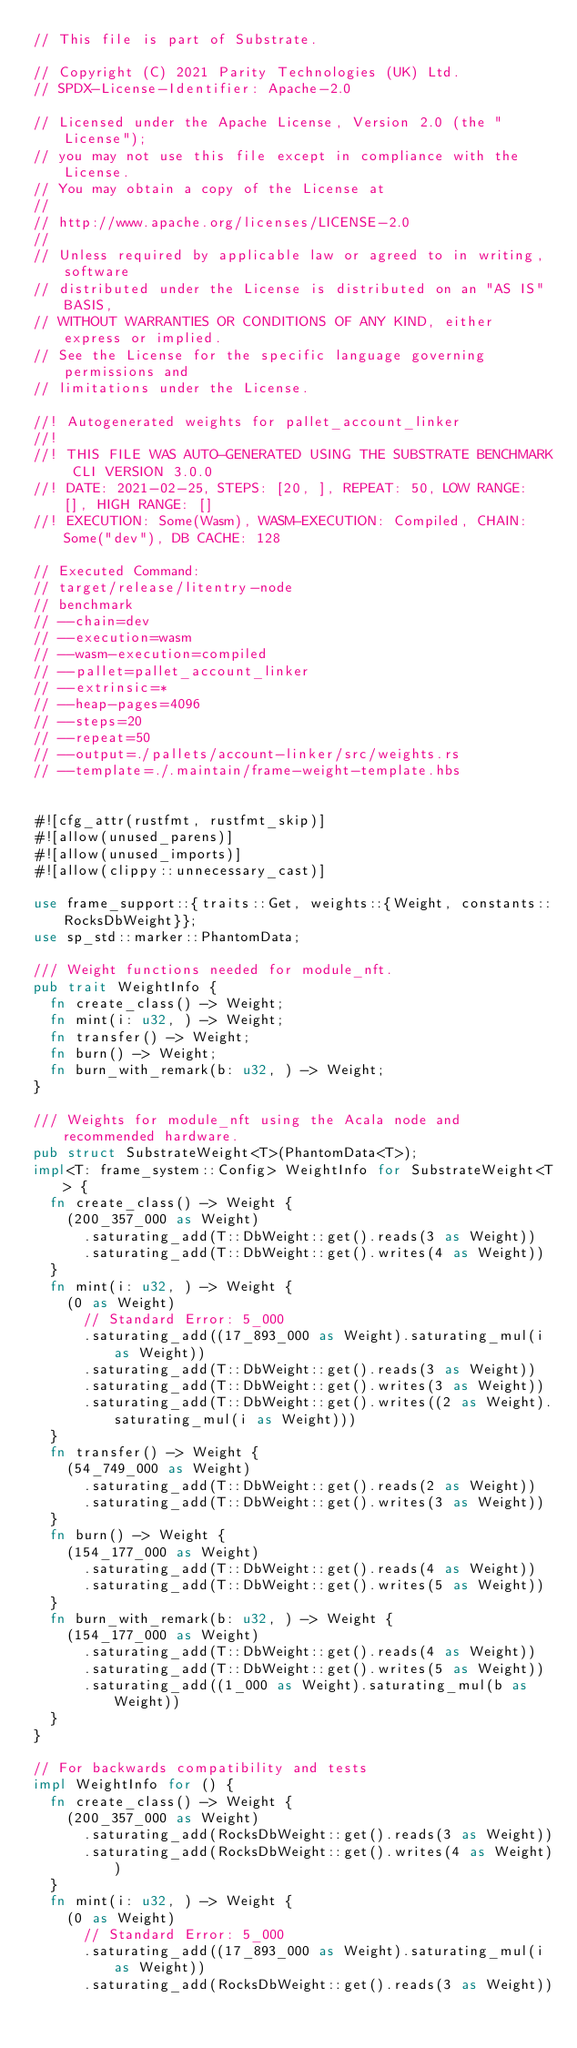Convert code to text. <code><loc_0><loc_0><loc_500><loc_500><_Rust_>// This file is part of Substrate.

// Copyright (C) 2021 Parity Technologies (UK) Ltd.
// SPDX-License-Identifier: Apache-2.0

// Licensed under the Apache License, Version 2.0 (the "License");
// you may not use this file except in compliance with the License.
// You may obtain a copy of the License at
//
// http://www.apache.org/licenses/LICENSE-2.0
//
// Unless required by applicable law or agreed to in writing, software
// distributed under the License is distributed on an "AS IS" BASIS,
// WITHOUT WARRANTIES OR CONDITIONS OF ANY KIND, either express or implied.
// See the License for the specific language governing permissions and
// limitations under the License.

//! Autogenerated weights for pallet_account_linker
//!
//! THIS FILE WAS AUTO-GENERATED USING THE SUBSTRATE BENCHMARK CLI VERSION 3.0.0
//! DATE: 2021-02-25, STEPS: [20, ], REPEAT: 50, LOW RANGE: [], HIGH RANGE: []
//! EXECUTION: Some(Wasm), WASM-EXECUTION: Compiled, CHAIN: Some("dev"), DB CACHE: 128

// Executed Command:
// target/release/litentry-node
// benchmark
// --chain=dev
// --execution=wasm
// --wasm-execution=compiled
// --pallet=pallet_account_linker
// --extrinsic=*
// --heap-pages=4096
// --steps=20
// --repeat=50
// --output=./pallets/account-linker/src/weights.rs
// --template=./.maintain/frame-weight-template.hbs


#![cfg_attr(rustfmt, rustfmt_skip)]
#![allow(unused_parens)]
#![allow(unused_imports)]
#![allow(clippy::unnecessary_cast)]

use frame_support::{traits::Get, weights::{Weight, constants::RocksDbWeight}};
use sp_std::marker::PhantomData;

/// Weight functions needed for module_nft.
pub trait WeightInfo {
	fn create_class() -> Weight;
	fn mint(i: u32, ) -> Weight;
	fn transfer() -> Weight;
	fn burn() -> Weight;
	fn burn_with_remark(b: u32, ) -> Weight;
}

/// Weights for module_nft using the Acala node and recommended hardware.
pub struct SubstrateWeight<T>(PhantomData<T>);
impl<T: frame_system::Config> WeightInfo for SubstrateWeight<T> {
	fn create_class() -> Weight {
		(200_357_000 as Weight)
			.saturating_add(T::DbWeight::get().reads(3 as Weight))
			.saturating_add(T::DbWeight::get().writes(4 as Weight))
	}
	fn mint(i: u32, ) -> Weight {
		(0 as Weight)
			// Standard Error: 5_000
			.saturating_add((17_893_000 as Weight).saturating_mul(i as Weight))
			.saturating_add(T::DbWeight::get().reads(3 as Weight))
			.saturating_add(T::DbWeight::get().writes(3 as Weight))
			.saturating_add(T::DbWeight::get().writes((2 as Weight).saturating_mul(i as Weight)))
	}
	fn transfer() -> Weight {
		(54_749_000 as Weight)
			.saturating_add(T::DbWeight::get().reads(2 as Weight))
			.saturating_add(T::DbWeight::get().writes(3 as Weight))
	}
	fn burn() -> Weight {
		(154_177_000 as Weight)
			.saturating_add(T::DbWeight::get().reads(4 as Weight))
			.saturating_add(T::DbWeight::get().writes(5 as Weight))
	}
	fn burn_with_remark(b: u32, ) -> Weight {
		(154_177_000 as Weight)
			.saturating_add(T::DbWeight::get().reads(4 as Weight))
			.saturating_add(T::DbWeight::get().writes(5 as Weight))
			.saturating_add((1_000 as Weight).saturating_mul(b as Weight))
	}
}

// For backwards compatibility and tests
impl WeightInfo for () {
	fn create_class() -> Weight {
		(200_357_000 as Weight)
			.saturating_add(RocksDbWeight::get().reads(3 as Weight))
			.saturating_add(RocksDbWeight::get().writes(4 as Weight))
	}
	fn mint(i: u32, ) -> Weight {
		(0 as Weight)
			// Standard Error: 5_000
			.saturating_add((17_893_000 as Weight).saturating_mul(i as Weight))
			.saturating_add(RocksDbWeight::get().reads(3 as Weight))</code> 